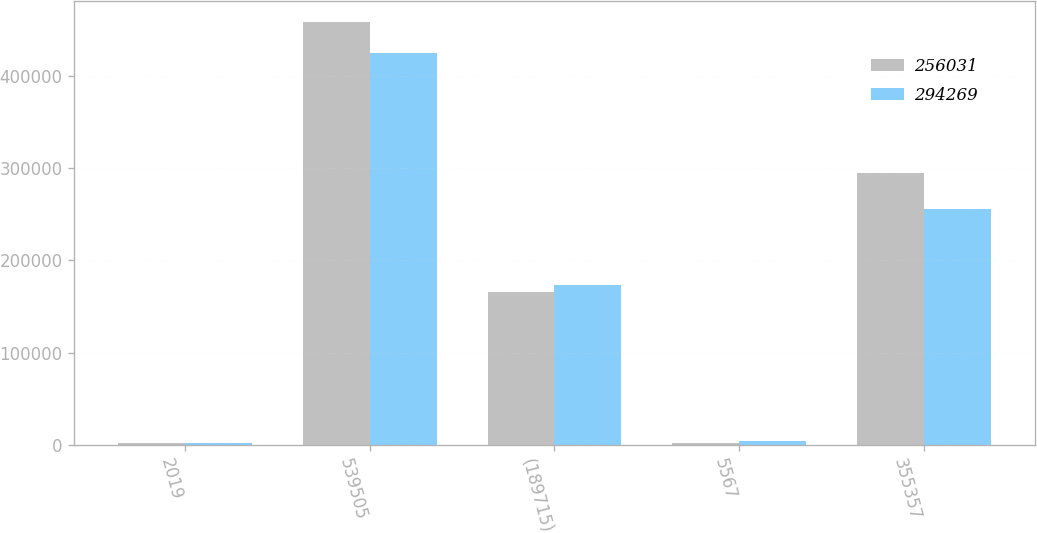Convert chart. <chart><loc_0><loc_0><loc_500><loc_500><stacked_bar_chart><ecel><fcel>2019<fcel>539505<fcel>(189715)<fcel>5567<fcel>355357<nl><fcel>256031<fcel>2018<fcel>457632<fcel>165457<fcel>2094<fcel>294269<nl><fcel>294269<fcel>2017<fcel>424086<fcel>172901<fcel>4846<fcel>256031<nl></chart> 